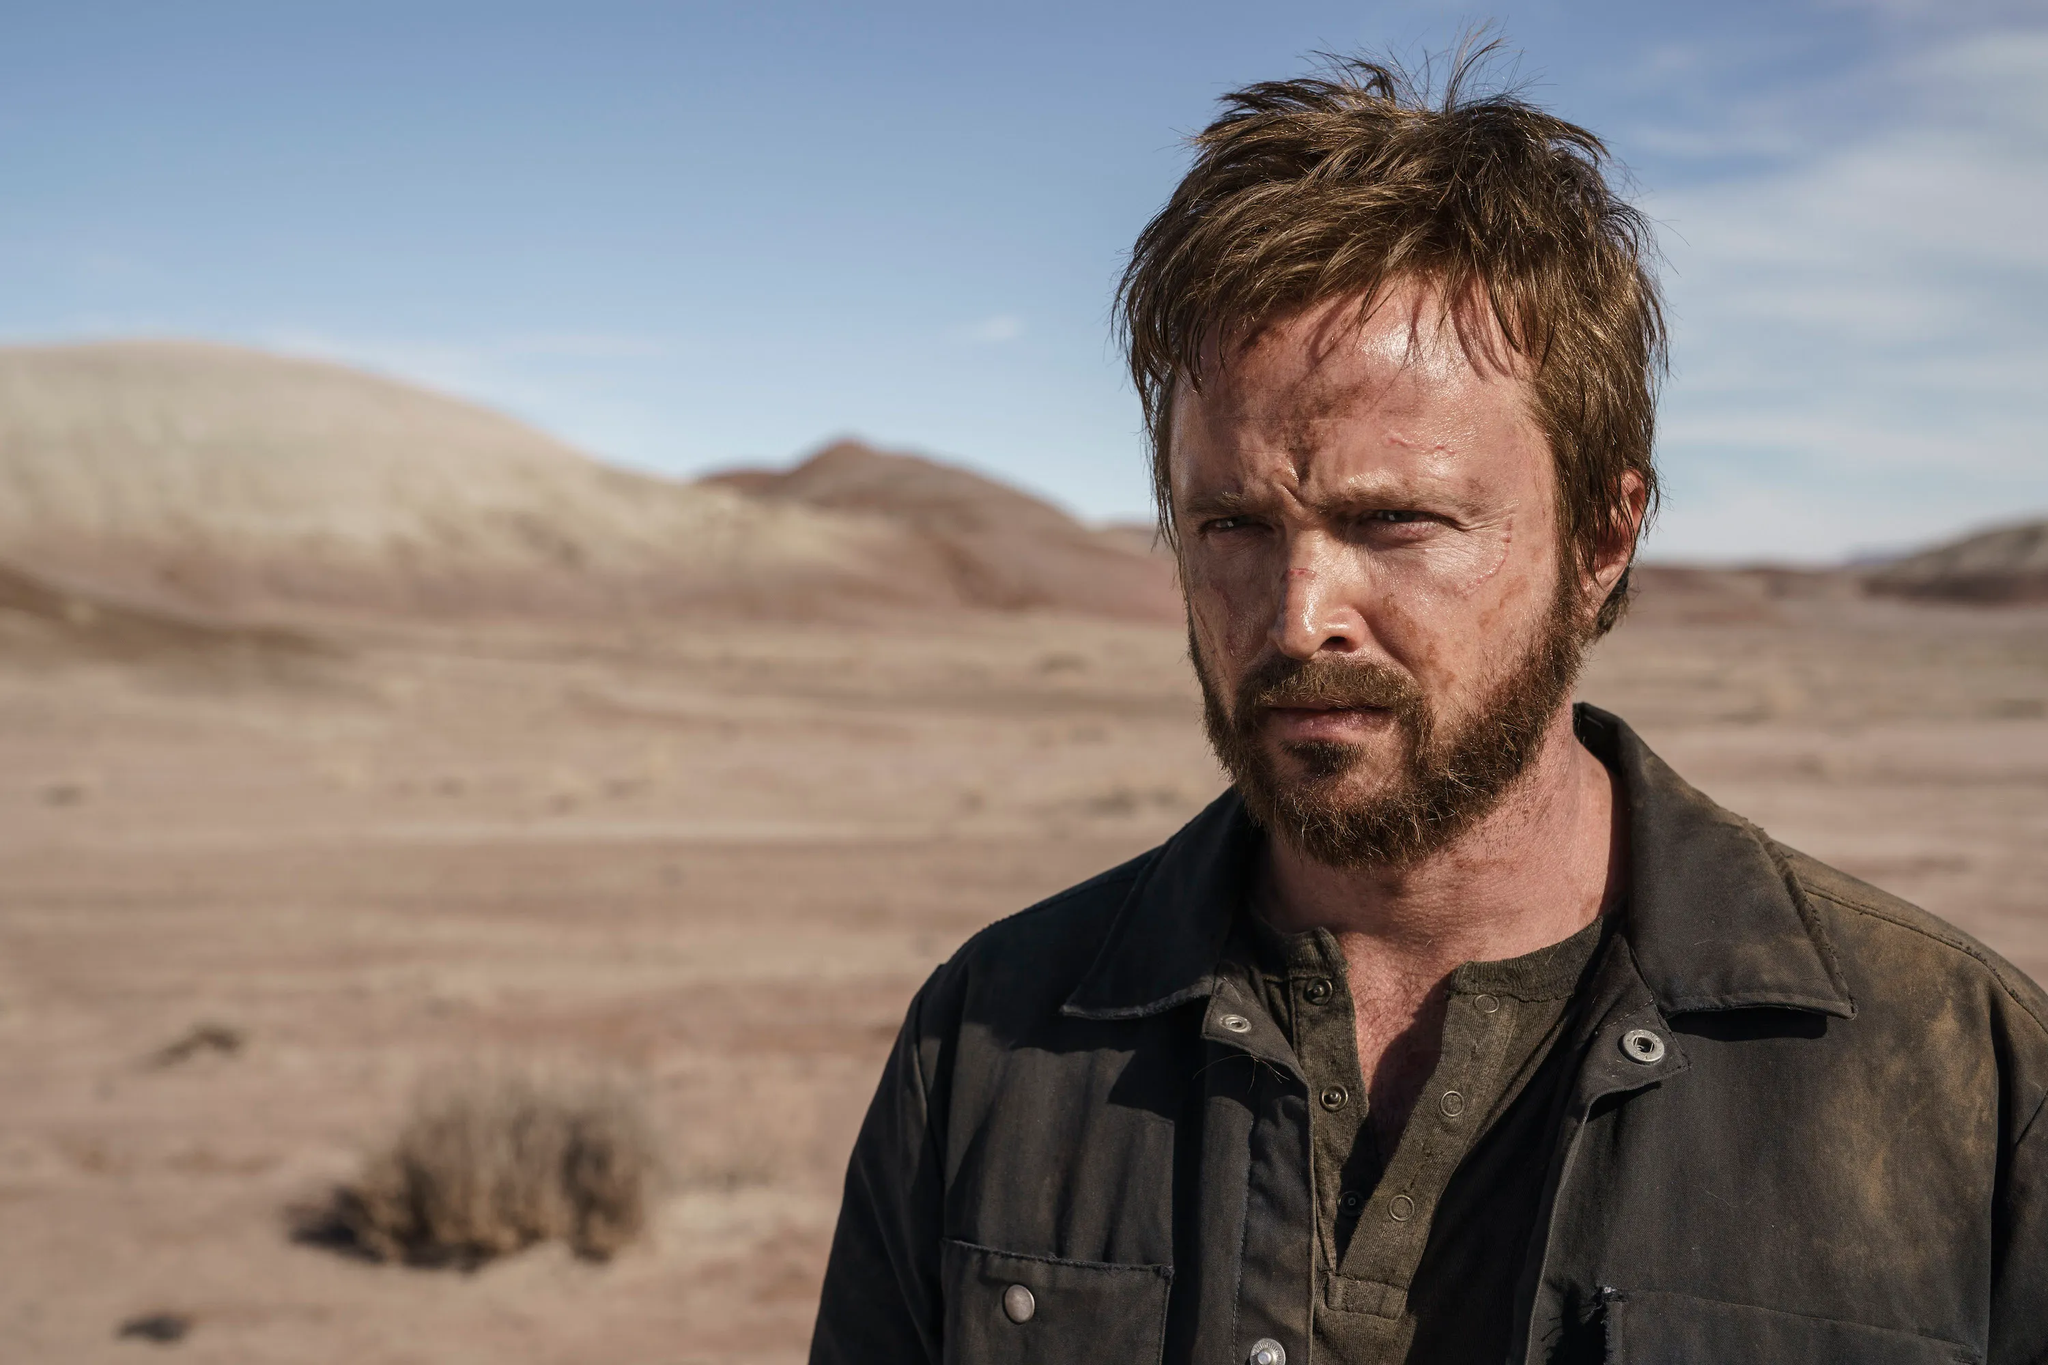What might be the time of day in this image? Based on the lighting and shadows in the image, it appears to be midday or early afternoon. The shadows cast are moderate in length, and the light is quite direct, which is typical for the time after midday peak sun but before the sun starts to significantly lower towards the horizon. 